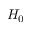Convert formula to latex. <formula><loc_0><loc_0><loc_500><loc_500>H _ { 0 }</formula> 